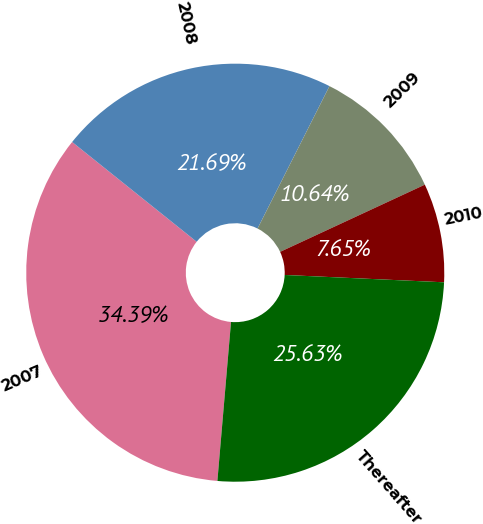Convert chart. <chart><loc_0><loc_0><loc_500><loc_500><pie_chart><fcel>2007<fcel>2008<fcel>2009<fcel>2010<fcel>Thereafter<nl><fcel>34.39%<fcel>21.69%<fcel>10.64%<fcel>7.65%<fcel>25.63%<nl></chart> 